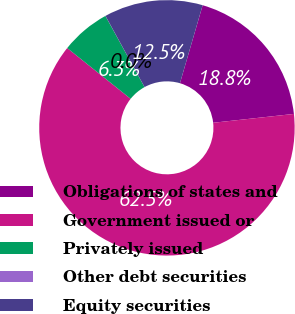<chart> <loc_0><loc_0><loc_500><loc_500><pie_chart><fcel>Obligations of states and<fcel>Government issued or<fcel>Privately issued<fcel>Other debt securities<fcel>Equity securities<nl><fcel>18.75%<fcel>62.47%<fcel>6.26%<fcel>0.01%<fcel>12.5%<nl></chart> 